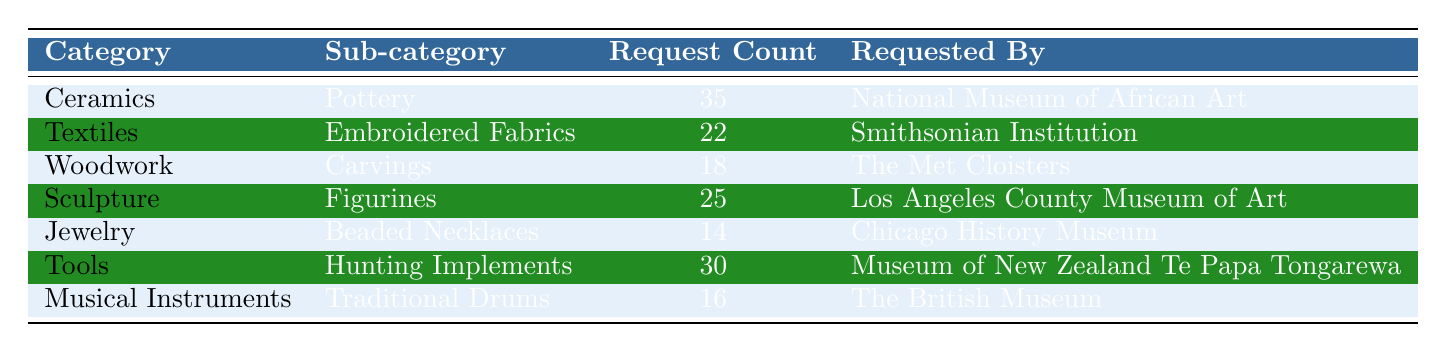What is the category with the highest request count? The row with the highest request count shows "Ceramics" with a request count of 35. Therefore, "Ceramics" is the category with the highest request count.
Answer: Ceramics How many request counts are there for "Textiles"? In the row for "Textiles," the request count is directly listed as 22. Therefore, the request count for "Textiles" is 22.
Answer: 22 Which institution requested "Jewelry"? The row detailing "Jewelry" indicates that the requested by institution is "Chicago History Museum." Thus, that is the institution that requested "Jewelry."
Answer: Chicago History Museum What is the total request count for "Tools" and "Musical Instruments"? The request count for "Tools" is 30 and for "Musical Instruments" it is 16. Adding these two counts gives 30 + 16 = 46. Therefore, the total request count for these categories is 46.
Answer: 46 Is there a request count of 14 for the "Ceramics" category? The request count for "Ceramics" is 35, which is greater than 14. Therefore, the statement is false.
Answer: No Which sub-category has the second highest request count? The request counts in descending order are 35 for "Pottery," 30 for "Hunting Implements," 25 for "Figurines," 22 for "Embroidered Fabrics," 18 for "Carvings," 16 for "Traditional Drums," and 14 for "Beaded Necklaces." The second highest is 30, which corresponds to the "Hunting Implements" sub-category in the "Tools" category.
Answer: Hunting Implements Are there more request counts for "Woodwork" compared to "Sculpture"? The request count for "Woodwork" is 18 and for "Sculpture" is 25. Since 18 is less than 25, the statement is false.
Answer: No What percentage of the total requests does "Jewelry" account for? The total request count across all categories is 35 + 22 + 18 + 25 + 14 + 30 + 16 = 150. "Jewelry" has a request count of 14. Therefore, the percentage is (14/150) * 100 = 9.33%.
Answer: 9.33% 